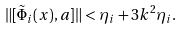<formula> <loc_0><loc_0><loc_500><loc_500>\| [ \tilde { \Phi } _ { i } ( x ) , a ] \| < \eta _ { i } + 3 k ^ { 2 } \eta _ { i } .</formula> 